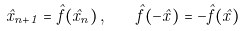<formula> <loc_0><loc_0><loc_500><loc_500>\hat { x } _ { n + 1 } = \hat { f } ( \hat { x } _ { n } ) \, , \quad \hat { f } ( - \hat { x } ) = - \hat { f } ( \hat { x } )</formula> 